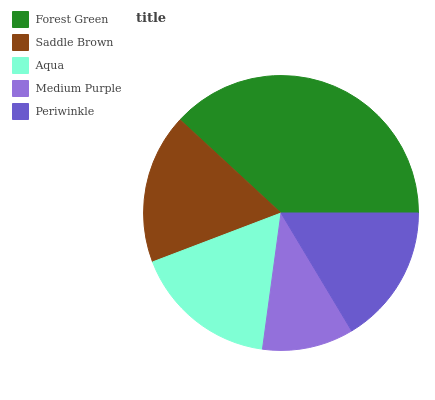Is Medium Purple the minimum?
Answer yes or no. Yes. Is Forest Green the maximum?
Answer yes or no. Yes. Is Saddle Brown the minimum?
Answer yes or no. No. Is Saddle Brown the maximum?
Answer yes or no. No. Is Forest Green greater than Saddle Brown?
Answer yes or no. Yes. Is Saddle Brown less than Forest Green?
Answer yes or no. Yes. Is Saddle Brown greater than Forest Green?
Answer yes or no. No. Is Forest Green less than Saddle Brown?
Answer yes or no. No. Is Aqua the high median?
Answer yes or no. Yes. Is Aqua the low median?
Answer yes or no. Yes. Is Saddle Brown the high median?
Answer yes or no. No. Is Forest Green the low median?
Answer yes or no. No. 